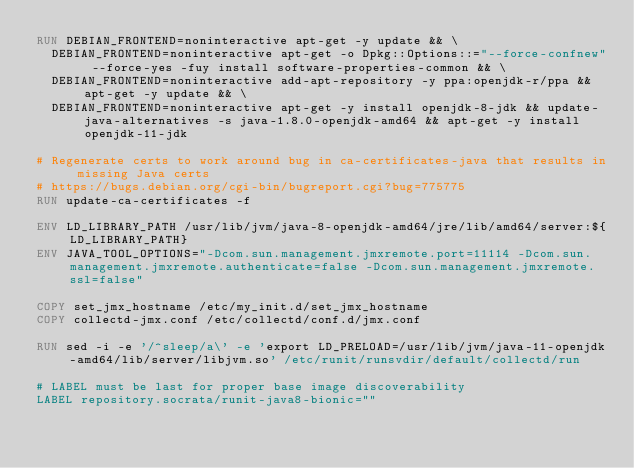<code> <loc_0><loc_0><loc_500><loc_500><_Dockerfile_>RUN DEBIAN_FRONTEND=noninteractive apt-get -y update && \
  DEBIAN_FRONTEND=noninteractive apt-get -o Dpkg::Options::="--force-confnew" --force-yes -fuy install software-properties-common && \
  DEBIAN_FRONTEND=noninteractive add-apt-repository -y ppa:openjdk-r/ppa && apt-get -y update && \
  DEBIAN_FRONTEND=noninteractive apt-get -y install openjdk-8-jdk && update-java-alternatives -s java-1.8.0-openjdk-amd64 && apt-get -y install openjdk-11-jdk

# Regenerate certs to work around bug in ca-certificates-java that results in missing Java certs
# https://bugs.debian.org/cgi-bin/bugreport.cgi?bug=775775
RUN update-ca-certificates -f

ENV LD_LIBRARY_PATH /usr/lib/jvm/java-8-openjdk-amd64/jre/lib/amd64/server:${LD_LIBRARY_PATH}
ENV JAVA_TOOL_OPTIONS="-Dcom.sun.management.jmxremote.port=11114 -Dcom.sun.management.jmxremote.authenticate=false -Dcom.sun.management.jmxremote.ssl=false"

COPY set_jmx_hostname /etc/my_init.d/set_jmx_hostname
COPY collectd-jmx.conf /etc/collectd/conf.d/jmx.conf

RUN sed -i -e '/^sleep/a\' -e 'export LD_PRELOAD=/usr/lib/jvm/java-11-openjdk-amd64/lib/server/libjvm.so' /etc/runit/runsvdir/default/collectd/run

# LABEL must be last for proper base image discoverability
LABEL repository.socrata/runit-java8-bionic=""
</code> 